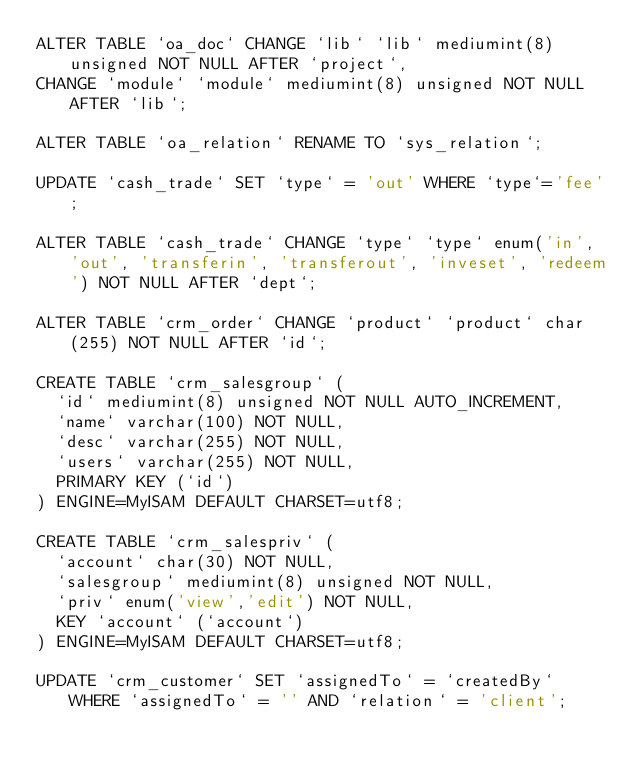<code> <loc_0><loc_0><loc_500><loc_500><_SQL_>ALTER TABLE `oa_doc` CHANGE `lib` `lib` mediumint(8) unsigned NOT NULL AFTER `project`,
CHANGE `module` `module` mediumint(8) unsigned NOT NULL AFTER `lib`;

ALTER TABLE `oa_relation` RENAME TO `sys_relation`;

UPDATE `cash_trade` SET `type` = 'out' WHERE `type`='fee';

ALTER TABLE `cash_trade` CHANGE `type` `type` enum('in', 'out', 'transferin', 'transferout', 'inveset', 'redeem') NOT NULL AFTER `dept`;

ALTER TABLE `crm_order` CHANGE `product` `product` char(255) NOT NULL AFTER `id`;

CREATE TABLE `crm_salesgroup` (
  `id` mediumint(8) unsigned NOT NULL AUTO_INCREMENT,
  `name` varchar(100) NOT NULL,
  `desc` varchar(255) NOT NULL,
  `users` varchar(255) NOT NULL,
  PRIMARY KEY (`id`)
) ENGINE=MyISAM DEFAULT CHARSET=utf8;

CREATE TABLE `crm_salespriv` (
  `account` char(30) NOT NULL,
  `salesgroup` mediumint(8) unsigned NOT NULL,
  `priv` enum('view','edit') NOT NULL,
  KEY `account` (`account`)
) ENGINE=MyISAM DEFAULT CHARSET=utf8;

UPDATE `crm_customer` SET `assignedTo` = `createdBy` WHERE `assignedTo` = '' AND `relation` = 'client';
</code> 